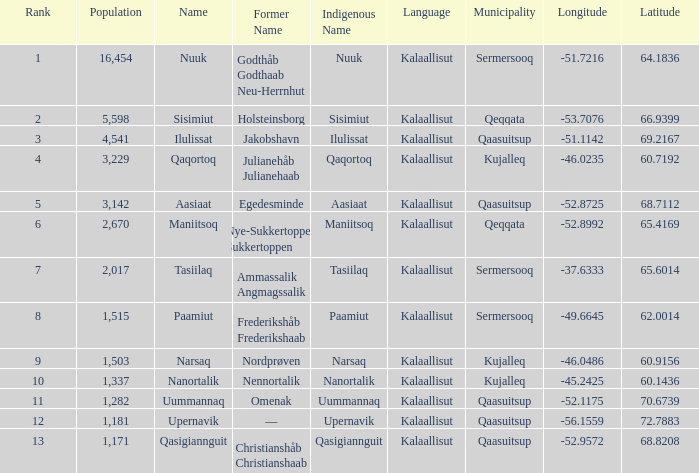What is the population for Rank 11? 1282.0. 